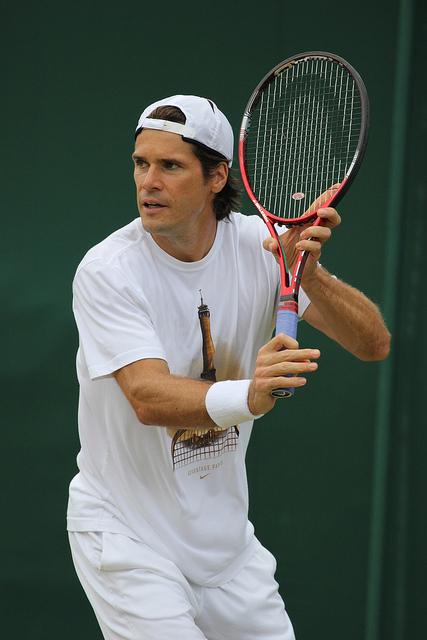What is above his watch on his wrist?
Concise answer only. Sweatband. What color are the man's pants?
Write a very short answer. White. What is the man holding?
Concise answer only. Tennis racket. What brand of shirt are they wearing?
Write a very short answer. Nike. What color is the background?
Keep it brief. Green. 